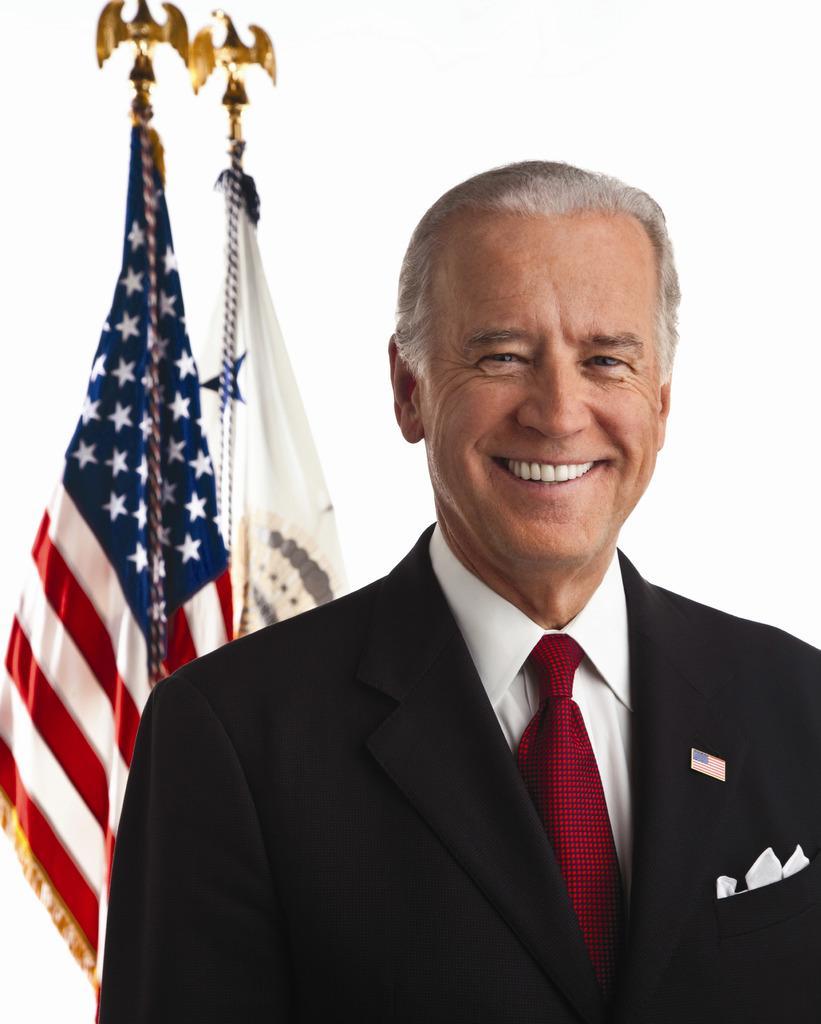Can you describe this image briefly? In this image in the front there is a person smiling. In the background there are flags. 